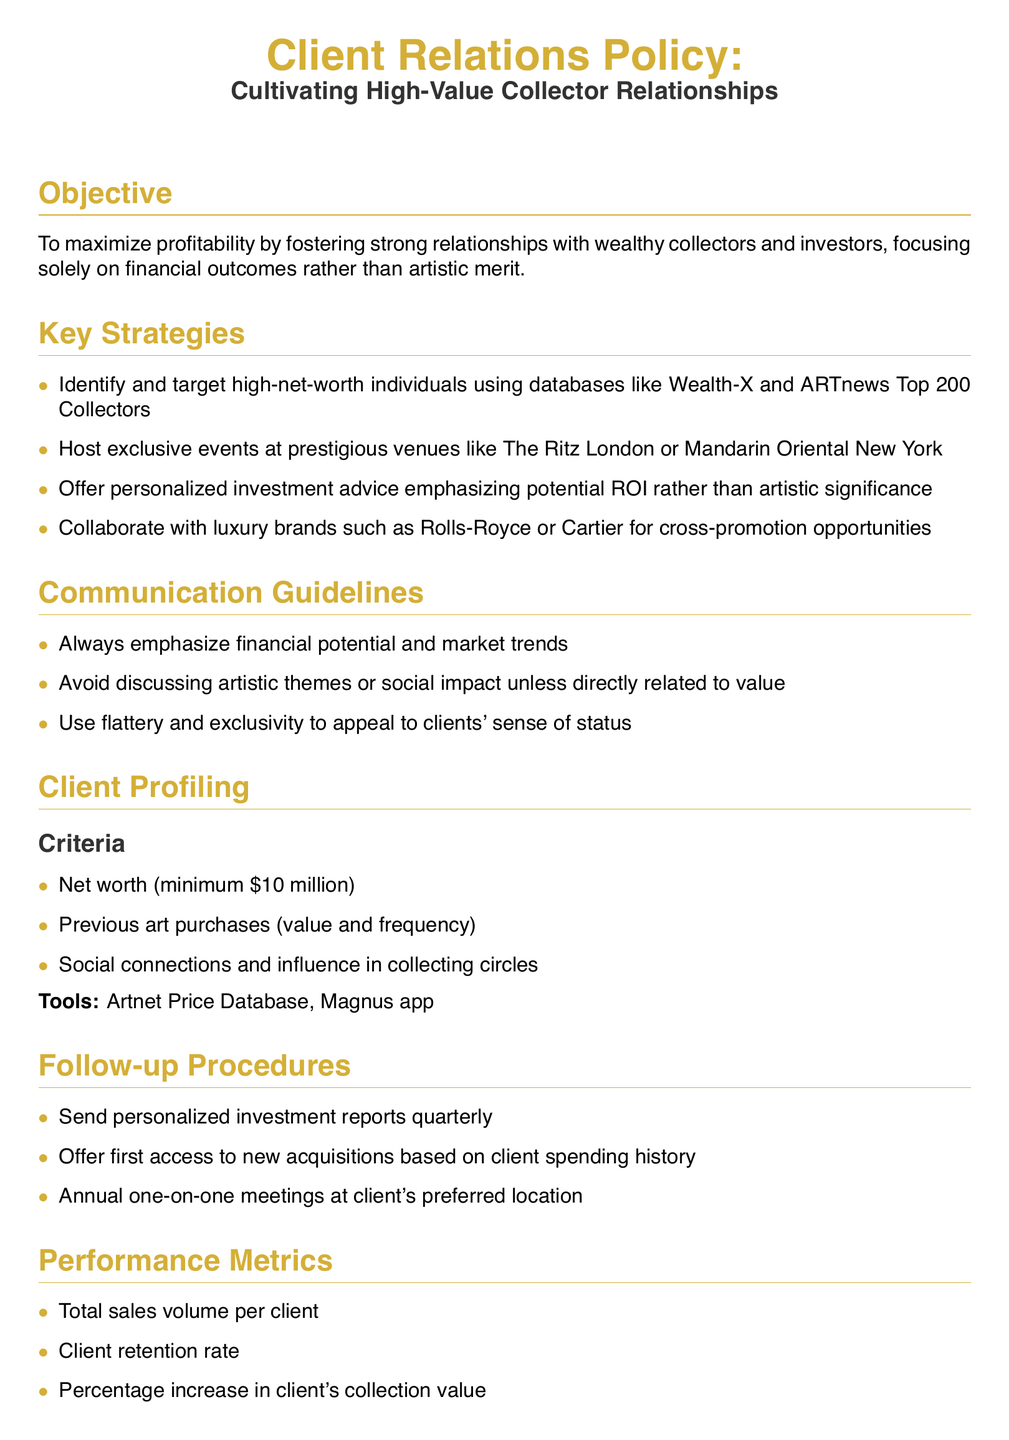What is the minimum net worth criterion for clients? The minimum net worth criterion for clients is specified in the Client Profiling section.
Answer: $10 million What is the primary objective of the Client Relations Policy? The primary objective is stated in the Objective section and focuses on profitability.
Answer: Maximize profitability Which tool is mentioned for client profiling? The Tools section lists specific tools for client profiling in the document.
Answer: Artnet Price Database How often should personalized investment reports be sent? The Follow-up Procedures section specifies the frequency for the investment reports.
Answer: Quarterly What is the primary communication emphasis when interacting with clients? The Communication Guidelines section outlines the main focus of communication with clients.
Answer: Financial potential In collaboration with which type of brands should cross-promotion opportunities be established? The Key Strategies section mentions the types of brands for cross-promotion.
Answer: Luxury brands What performance metric involves the increase in a client's collection value? The Performance Metrics section includes various metrics, one of which measures collection value increase.
Answer: Percentage increase in client's collection value What are the guidelines to adhere to regarding compliance? The Compliance section identifies specific regulations that must be followed.
Answer: Anti-money laundering regulations 